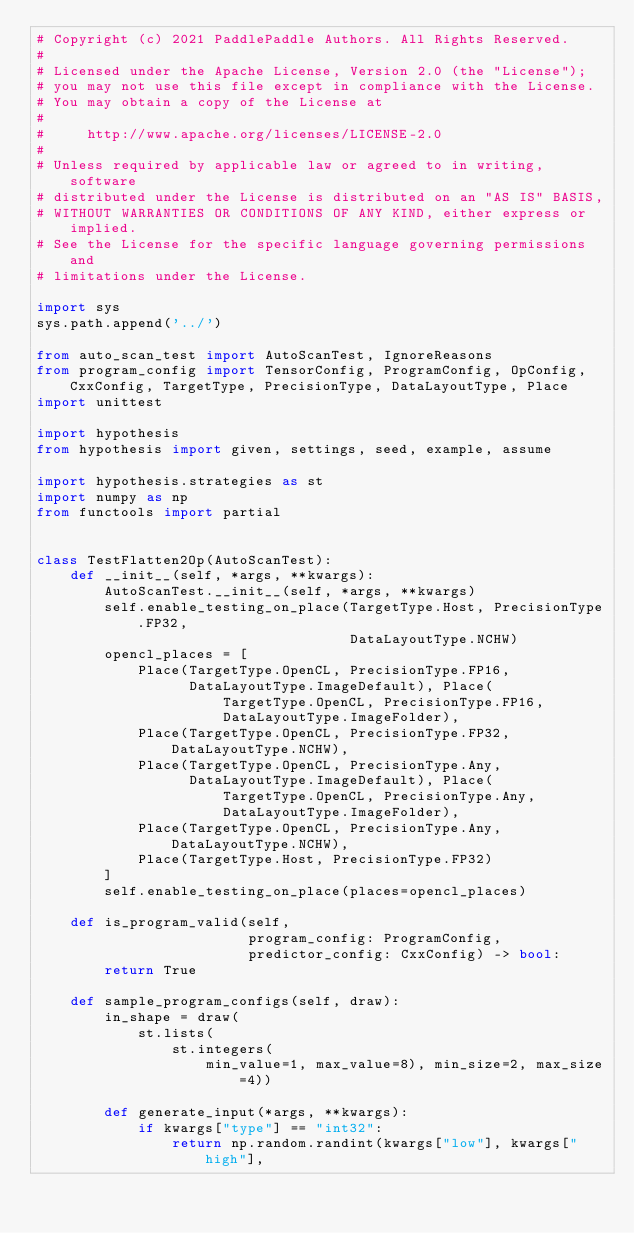Convert code to text. <code><loc_0><loc_0><loc_500><loc_500><_Python_># Copyright (c) 2021 PaddlePaddle Authors. All Rights Reserved.
#
# Licensed under the Apache License, Version 2.0 (the "License");
# you may not use this file except in compliance with the License.
# You may obtain a copy of the License at
#
#     http://www.apache.org/licenses/LICENSE-2.0
#
# Unless required by applicable law or agreed to in writing, software
# distributed under the License is distributed on an "AS IS" BASIS,
# WITHOUT WARRANTIES OR CONDITIONS OF ANY KIND, either express or implied.
# See the License for the specific language governing permissions and
# limitations under the License.

import sys
sys.path.append('../')

from auto_scan_test import AutoScanTest, IgnoreReasons
from program_config import TensorConfig, ProgramConfig, OpConfig, CxxConfig, TargetType, PrecisionType, DataLayoutType, Place
import unittest

import hypothesis
from hypothesis import given, settings, seed, example, assume

import hypothesis.strategies as st
import numpy as np
from functools import partial


class TestFlatten2Op(AutoScanTest):
    def __init__(self, *args, **kwargs):
        AutoScanTest.__init__(self, *args, **kwargs)
        self.enable_testing_on_place(TargetType.Host, PrecisionType.FP32,
                                     DataLayoutType.NCHW)
        opencl_places = [
            Place(TargetType.OpenCL, PrecisionType.FP16,
                  DataLayoutType.ImageDefault), Place(
                      TargetType.OpenCL, PrecisionType.FP16,
                      DataLayoutType.ImageFolder),
            Place(TargetType.OpenCL, PrecisionType.FP32, DataLayoutType.NCHW),
            Place(TargetType.OpenCL, PrecisionType.Any,
                  DataLayoutType.ImageDefault), Place(
                      TargetType.OpenCL, PrecisionType.Any,
                      DataLayoutType.ImageFolder),
            Place(TargetType.OpenCL, PrecisionType.Any, DataLayoutType.NCHW),
            Place(TargetType.Host, PrecisionType.FP32)
        ]
        self.enable_testing_on_place(places=opencl_places)

    def is_program_valid(self,
                         program_config: ProgramConfig,
                         predictor_config: CxxConfig) -> bool:
        return True

    def sample_program_configs(self, draw):
        in_shape = draw(
            st.lists(
                st.integers(
                    min_value=1, max_value=8), min_size=2, max_size=4))

        def generate_input(*args, **kwargs):
            if kwargs["type"] == "int32":
                return np.random.randint(kwargs["low"], kwargs["high"],</code> 